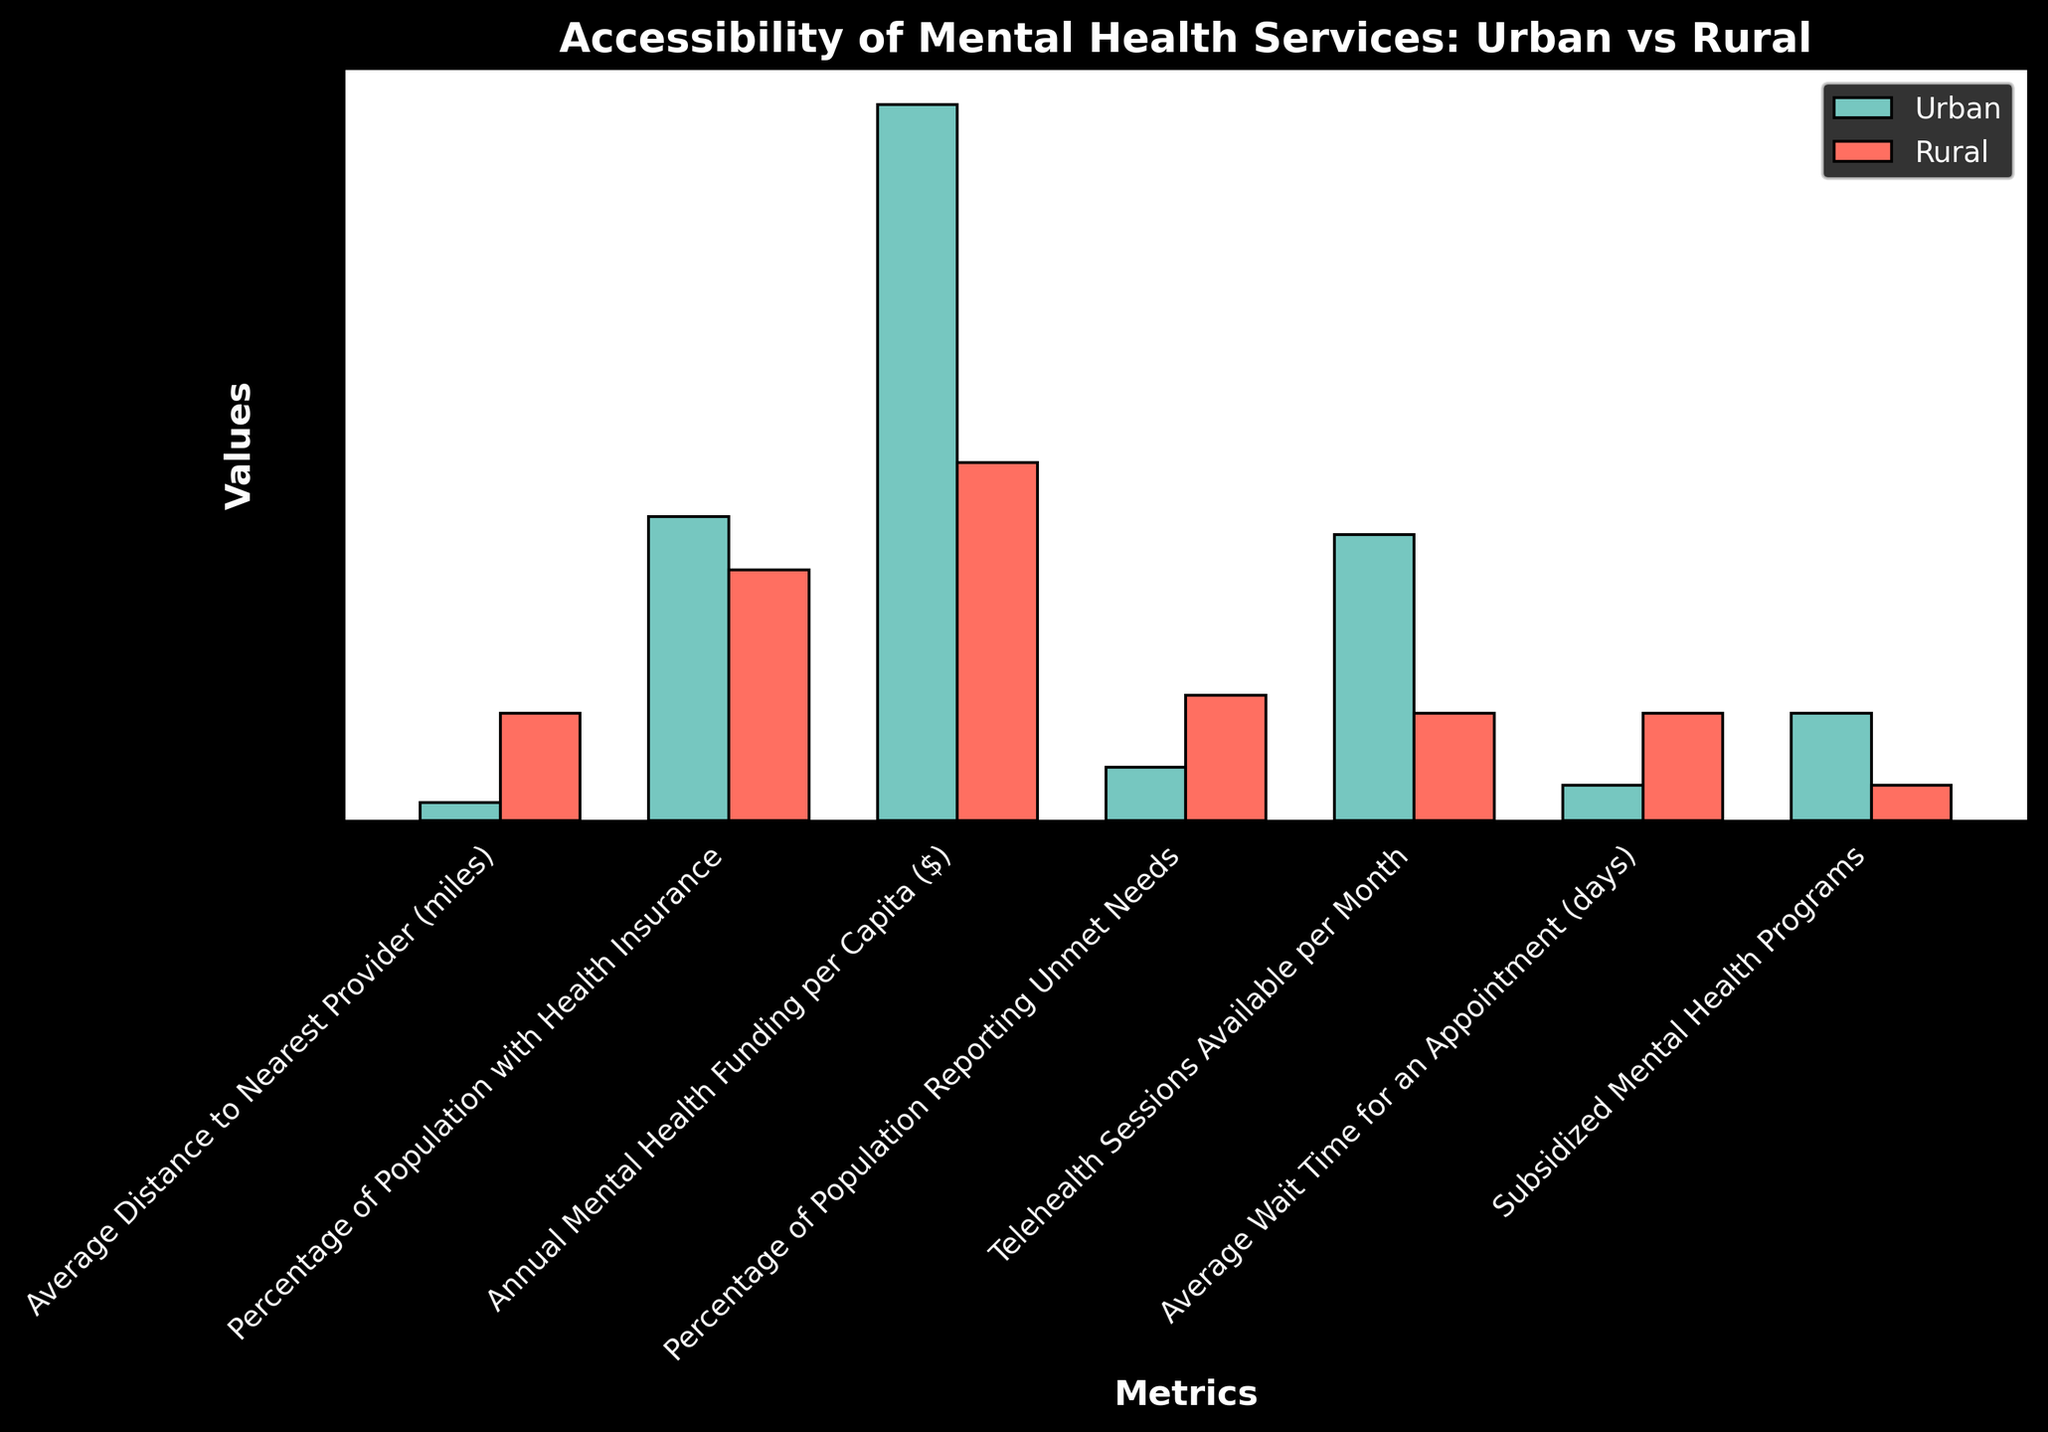What is the average distance to the nearest provider in rural areas compared to urban areas? The chart shows that the average distance to the nearest provider in urban areas is 5 miles and in rural areas is 30 miles. So, the distance in rural areas is the miles difference between these two values.
Answer: 25 miles Which area has a higher percentage of the population with health insurance? The chart indicates 85% for urban areas and 70% for rural areas. Since 85% is greater than 70%, urban areas have a higher percentage of the population with health insurance.
Answer: Urban What is the difference in annual mental health funding per capita between urban and rural areas? According to the chart, the funding per capita is $200 in urban areas and $100 in rural areas. The difference is $200 - $100.
Answer: $100 How many more telehealth sessions are available per month in urban areas compared to rural areas? The chart shows 80 sessions for urban areas and 30 sessions for rural areas. The difference is 80 - 30.
Answer: 50 sessions Which area has a lower percentage of the population reporting unmet needs? The chart indicates 15% in urban areas and 35% in rural areas. Since 15% is lower than 35%, urban areas have a lower percentage of the population reporting unmet needs.
Answer: Urban What is the difference in the average wait time for an appointment between urban and rural areas? The average wait time is 10 days in urban areas and 30 days in rural areas. The difference is 30 - 10.
Answer: 20 days What is the total percentage of the population with health insurance in both urban and rural areas? The urban percentage is 85% and the rural percentage is 70%. So, the total is 85 + 70.
Answer: 155% Which area has more subsidized mental health programs? The chart shows 30 programs in urban areas and 10 programs in rural areas. Thus, urban areas have more subsidized mental health programs.
Answer: Urban How much more funding is provided per capita annually in urban areas compared to rural areas? Funding in urban areas is $200 per capita and in rural areas is $100 per capita. The additional funding is $200 - $100.
Answer: $100 